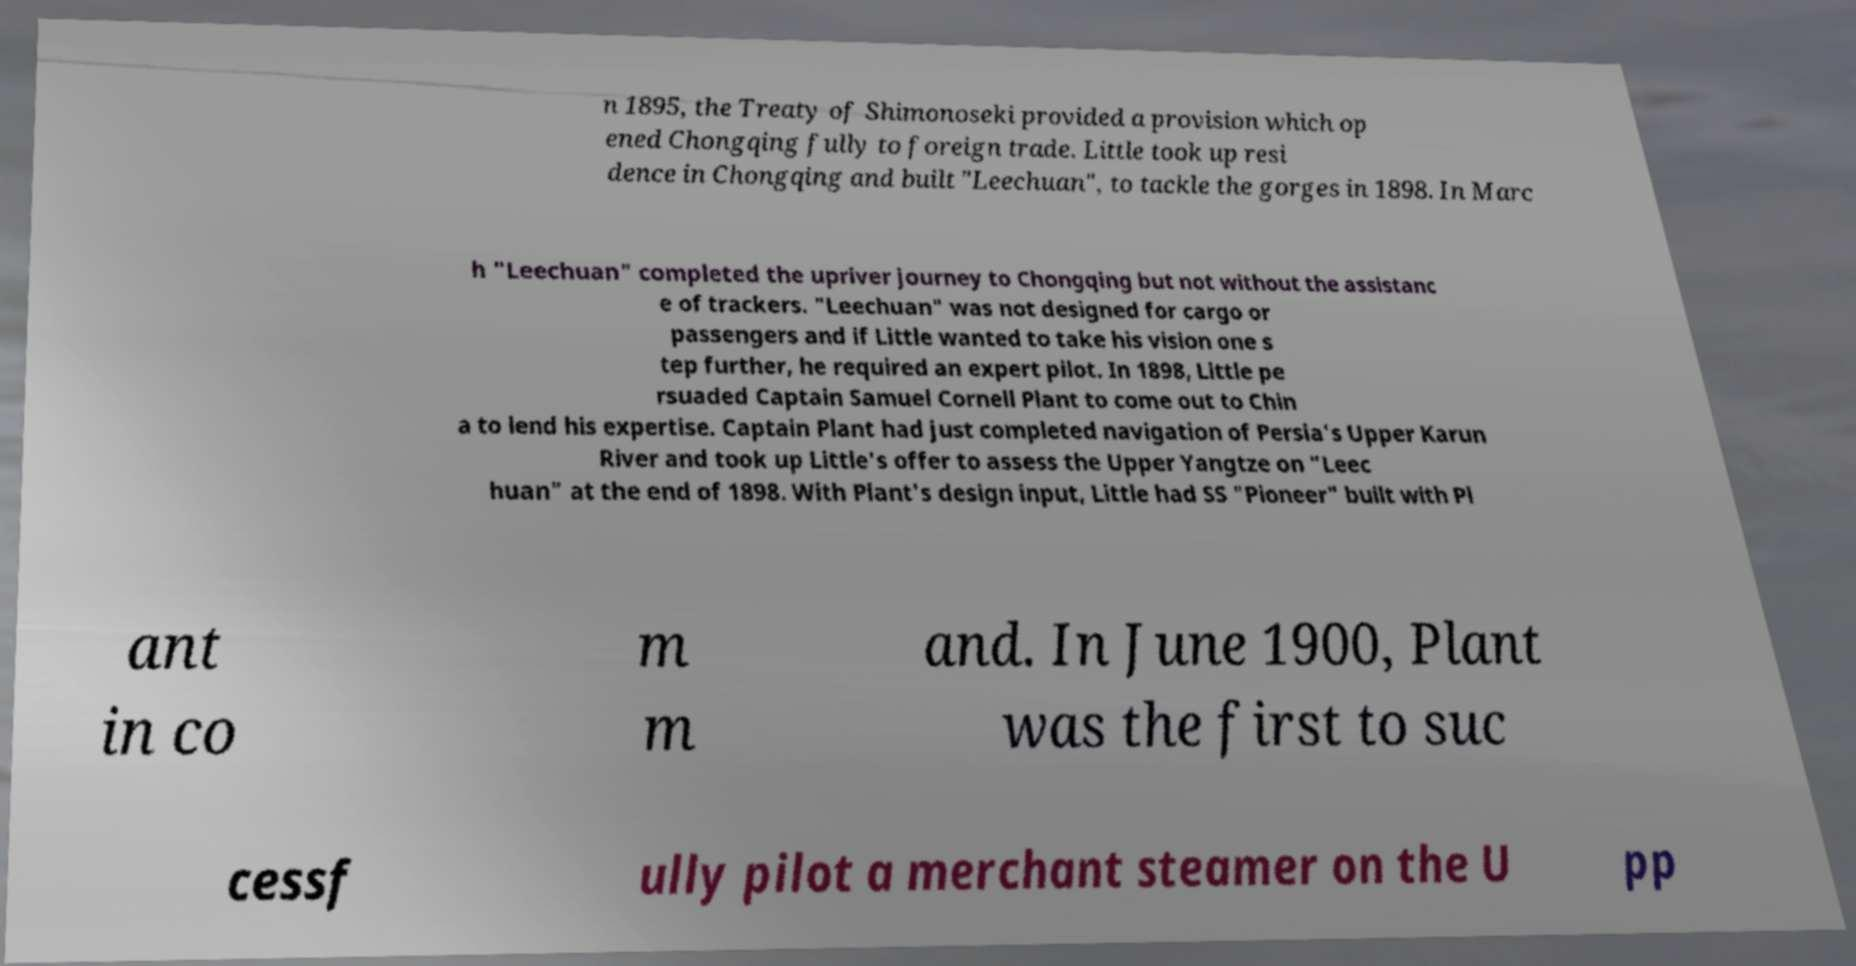Can you accurately transcribe the text from the provided image for me? n 1895, the Treaty of Shimonoseki provided a provision which op ened Chongqing fully to foreign trade. Little took up resi dence in Chongqing and built "Leechuan", to tackle the gorges in 1898. In Marc h "Leechuan" completed the upriver journey to Chongqing but not without the assistanc e of trackers. "Leechuan" was not designed for cargo or passengers and if Little wanted to take his vision one s tep further, he required an expert pilot. In 1898, Little pe rsuaded Captain Samuel Cornell Plant to come out to Chin a to lend his expertise. Captain Plant had just completed navigation of Persia's Upper Karun River and took up Little's offer to assess the Upper Yangtze on "Leec huan" at the end of 1898. With Plant's design input, Little had SS "Pioneer" built with Pl ant in co m m and. In June 1900, Plant was the first to suc cessf ully pilot a merchant steamer on the U pp 